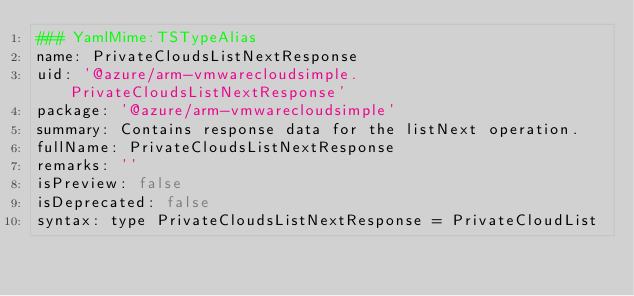<code> <loc_0><loc_0><loc_500><loc_500><_YAML_>### YamlMime:TSTypeAlias
name: PrivateCloudsListNextResponse
uid: '@azure/arm-vmwarecloudsimple.PrivateCloudsListNextResponse'
package: '@azure/arm-vmwarecloudsimple'
summary: Contains response data for the listNext operation.
fullName: PrivateCloudsListNextResponse
remarks: ''
isPreview: false
isDeprecated: false
syntax: type PrivateCloudsListNextResponse = PrivateCloudList
</code> 